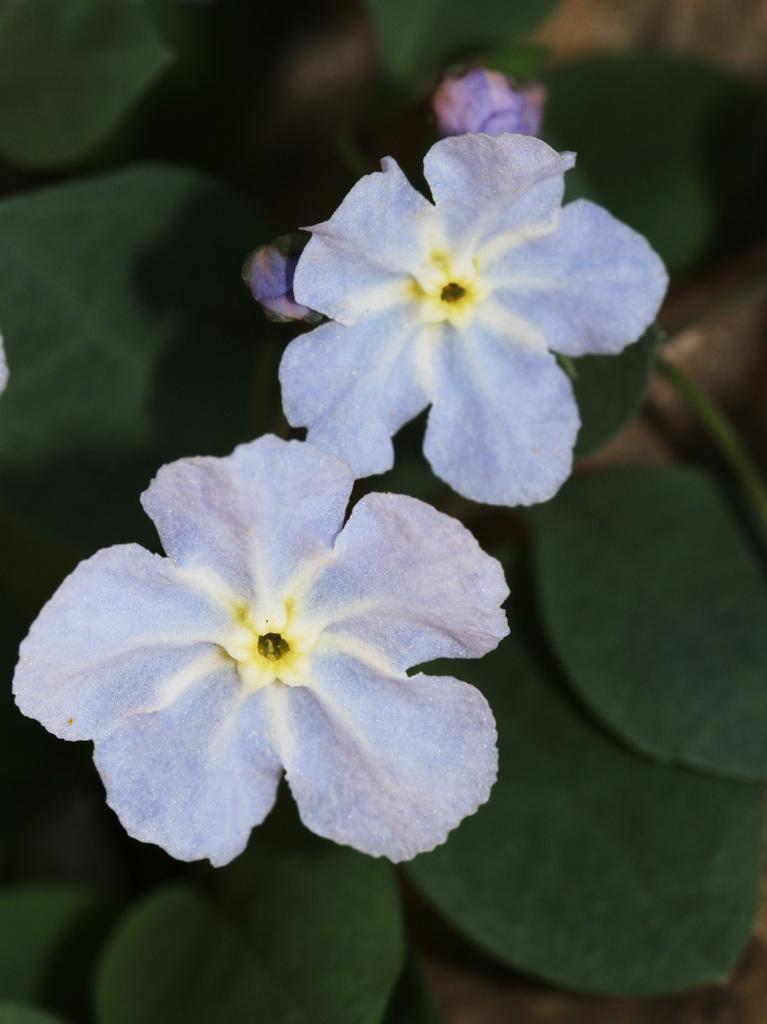Describe this image in one or two sentences. In this image there is a plant having few flowers, buds and leaves. 